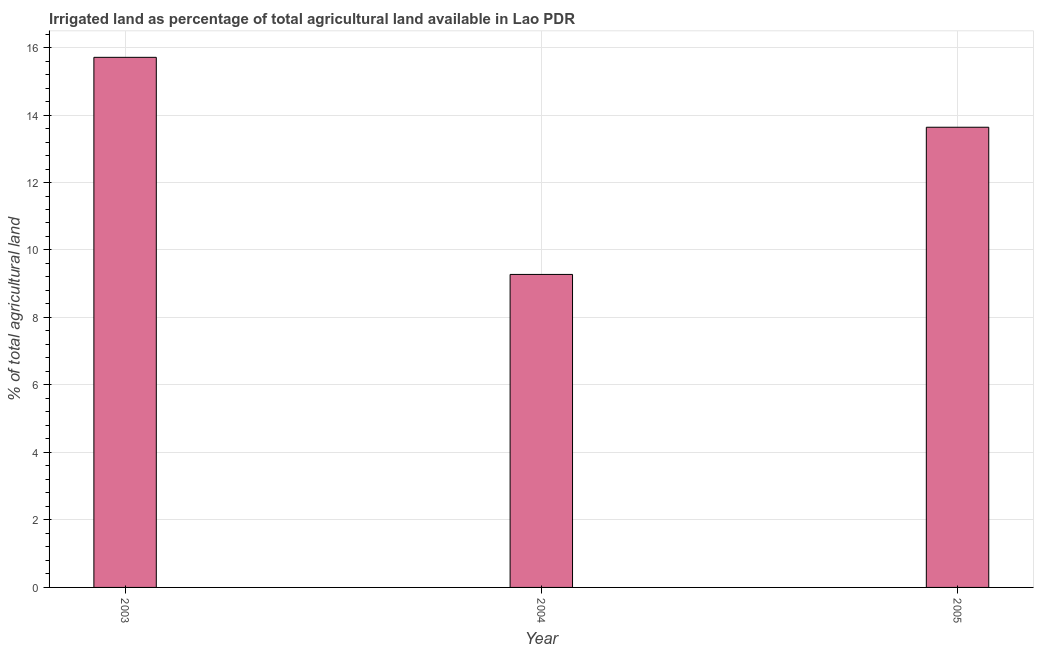Does the graph contain any zero values?
Your answer should be compact. No. What is the title of the graph?
Keep it short and to the point. Irrigated land as percentage of total agricultural land available in Lao PDR. What is the label or title of the X-axis?
Your answer should be very brief. Year. What is the label or title of the Y-axis?
Make the answer very short. % of total agricultural land. What is the percentage of agricultural irrigated land in 2005?
Offer a very short reply. 13.64. Across all years, what is the maximum percentage of agricultural irrigated land?
Provide a succinct answer. 15.71. Across all years, what is the minimum percentage of agricultural irrigated land?
Provide a short and direct response. 9.28. In which year was the percentage of agricultural irrigated land minimum?
Give a very brief answer. 2004. What is the sum of the percentage of agricultural irrigated land?
Make the answer very short. 38.62. What is the difference between the percentage of agricultural irrigated land in 2003 and 2004?
Your answer should be compact. 6.43. What is the average percentage of agricultural irrigated land per year?
Offer a very short reply. 12.87. What is the median percentage of agricultural irrigated land?
Provide a succinct answer. 13.64. In how many years, is the percentage of agricultural irrigated land greater than 9.6 %?
Make the answer very short. 2. Do a majority of the years between 2003 and 2004 (inclusive) have percentage of agricultural irrigated land greater than 10 %?
Ensure brevity in your answer.  No. What is the ratio of the percentage of agricultural irrigated land in 2003 to that in 2004?
Keep it short and to the point. 1.69. Is the percentage of agricultural irrigated land in 2003 less than that in 2005?
Your answer should be compact. No. Is the difference between the percentage of agricultural irrigated land in 2004 and 2005 greater than the difference between any two years?
Your response must be concise. No. What is the difference between the highest and the second highest percentage of agricultural irrigated land?
Provide a short and direct response. 2.07. Is the sum of the percentage of agricultural irrigated land in 2003 and 2004 greater than the maximum percentage of agricultural irrigated land across all years?
Your response must be concise. Yes. What is the difference between the highest and the lowest percentage of agricultural irrigated land?
Give a very brief answer. 6.43. In how many years, is the percentage of agricultural irrigated land greater than the average percentage of agricultural irrigated land taken over all years?
Ensure brevity in your answer.  2. Are all the bars in the graph horizontal?
Offer a very short reply. No. How many years are there in the graph?
Offer a very short reply. 3. Are the values on the major ticks of Y-axis written in scientific E-notation?
Offer a very short reply. No. What is the % of total agricultural land of 2003?
Your response must be concise. 15.71. What is the % of total agricultural land of 2004?
Your response must be concise. 9.28. What is the % of total agricultural land of 2005?
Offer a very short reply. 13.64. What is the difference between the % of total agricultural land in 2003 and 2004?
Give a very brief answer. 6.43. What is the difference between the % of total agricultural land in 2003 and 2005?
Your answer should be compact. 2.07. What is the difference between the % of total agricultural land in 2004 and 2005?
Your answer should be very brief. -4.36. What is the ratio of the % of total agricultural land in 2003 to that in 2004?
Your answer should be very brief. 1.69. What is the ratio of the % of total agricultural land in 2003 to that in 2005?
Your answer should be compact. 1.15. What is the ratio of the % of total agricultural land in 2004 to that in 2005?
Your response must be concise. 0.68. 